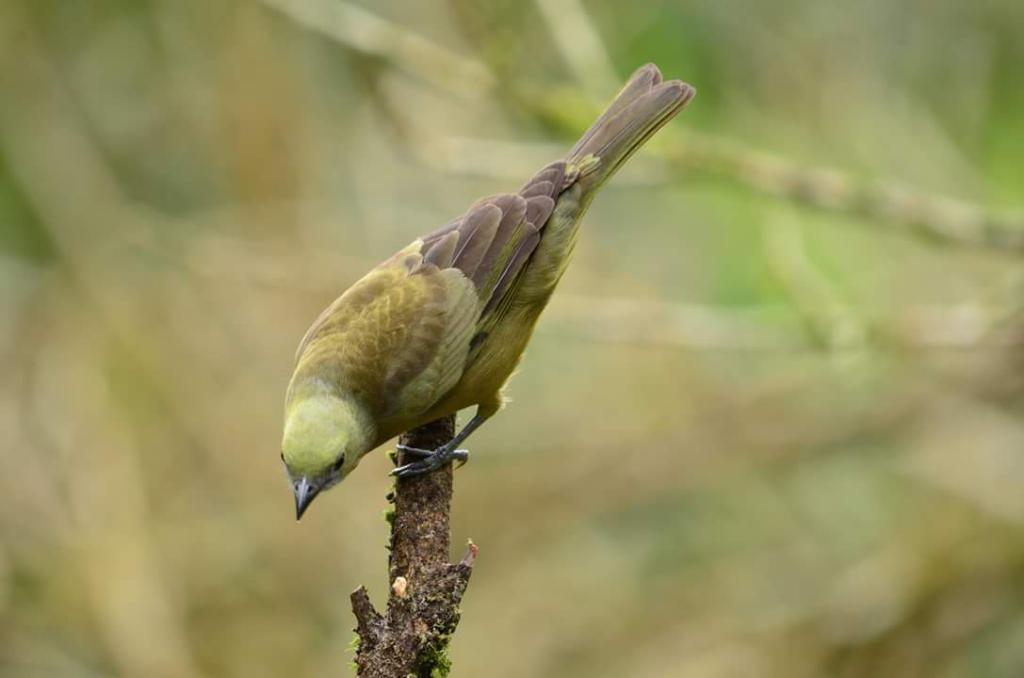How would you summarize this image in a sentence or two? In this image there is a bird on the stem. 